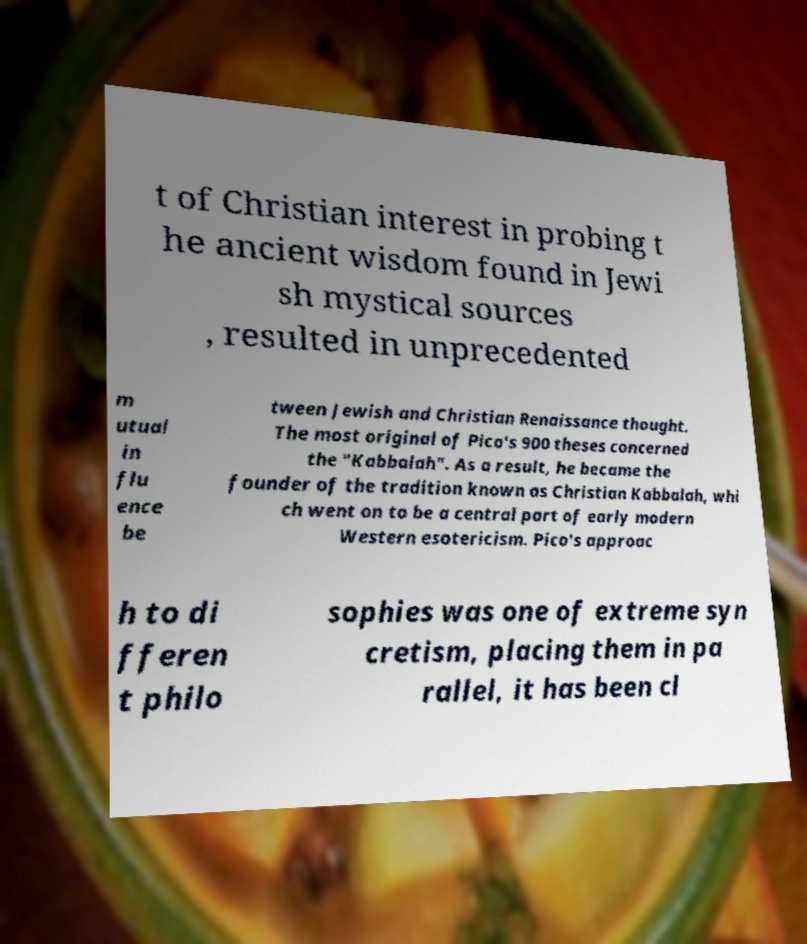There's text embedded in this image that I need extracted. Can you transcribe it verbatim? t of Christian interest in probing t he ancient wisdom found in Jewi sh mystical sources , resulted in unprecedented m utual in flu ence be tween Jewish and Christian Renaissance thought. The most original of Pico's 900 theses concerned the "Kabbalah". As a result, he became the founder of the tradition known as Christian Kabbalah, whi ch went on to be a central part of early modern Western esotericism. Pico's approac h to di fferen t philo sophies was one of extreme syn cretism, placing them in pa rallel, it has been cl 